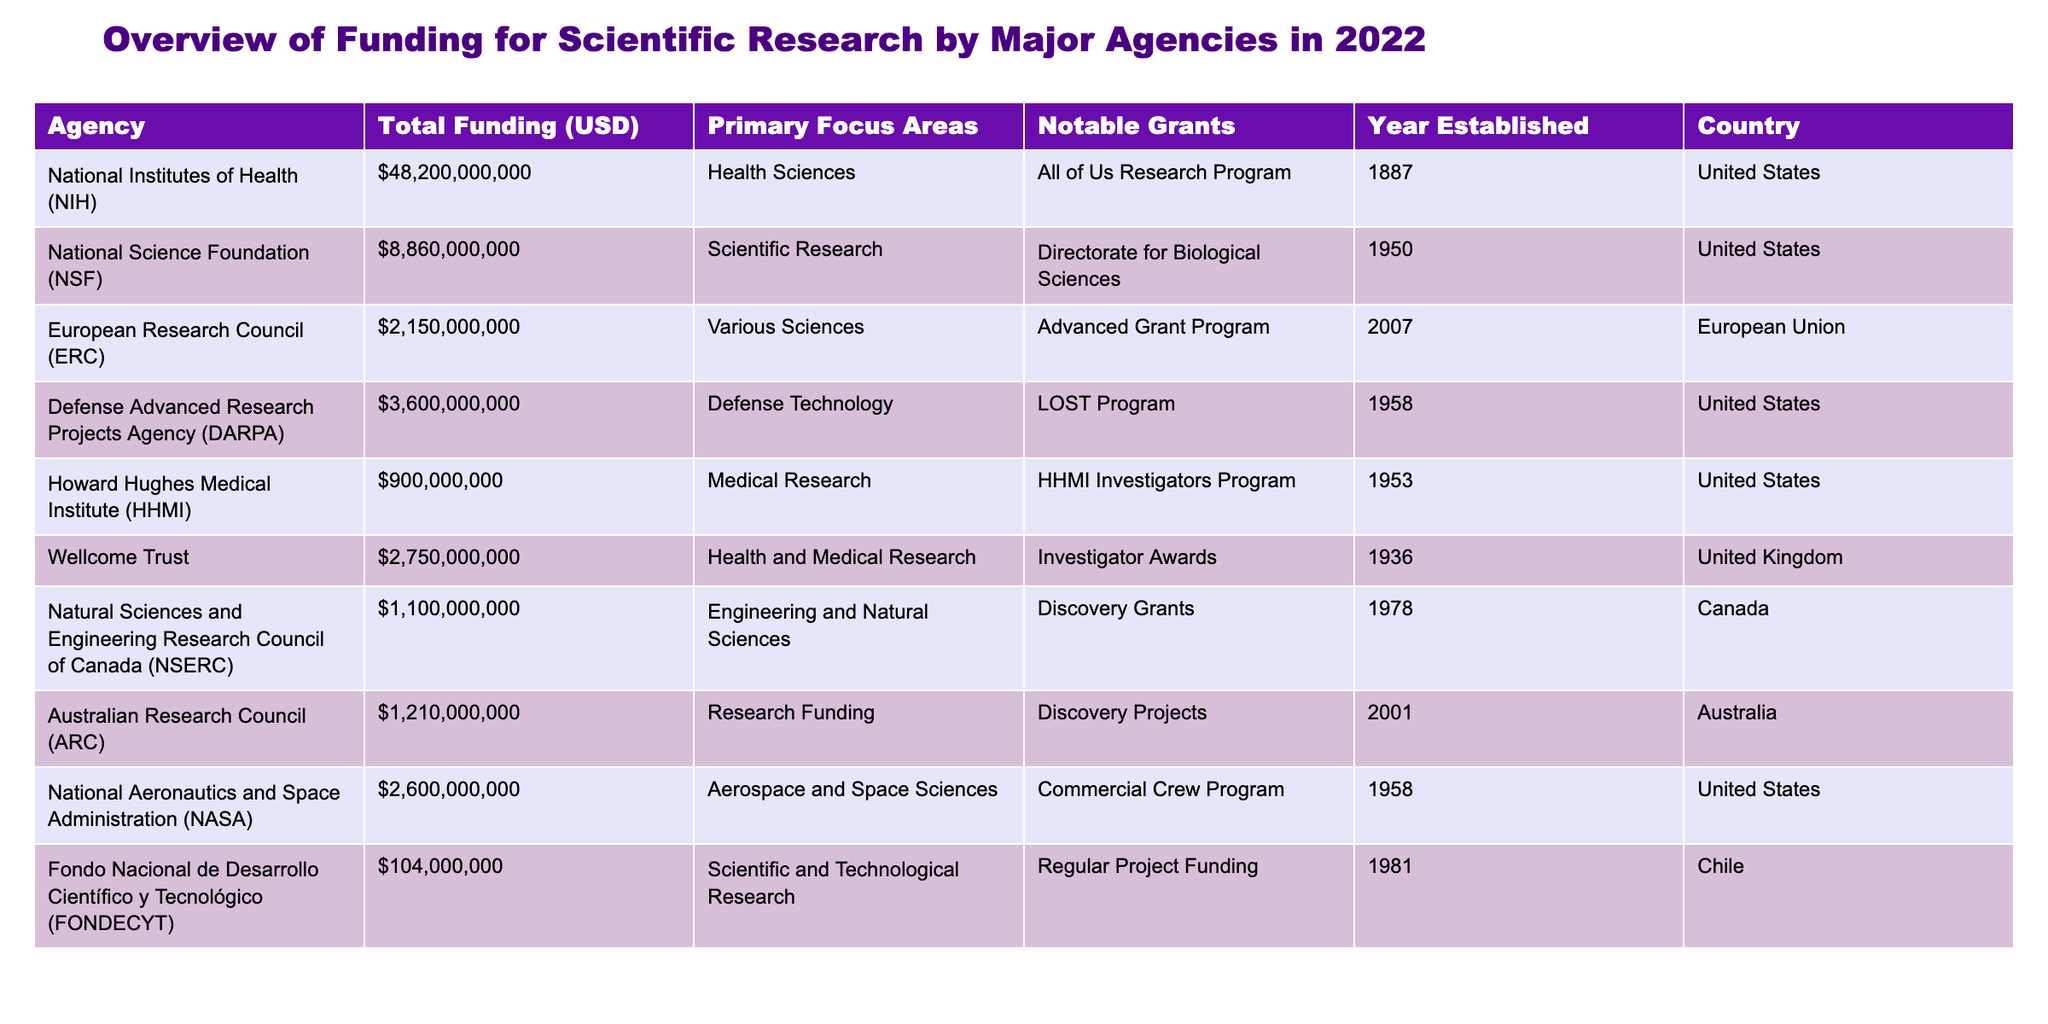What is the total funding provided by the National Institutes of Health (NIH)? The table shows that the total funding provided by the National Institutes of Health (NIH) is USD 48,200,000,000. This can be found in the "Total Funding (USD)" column corresponding to the row for NIH.
Answer: 48,200,000,000 Which agency focuses on defense technology and how much funding did it receive? The agency that focuses on defense technology is the Defense Advanced Research Projects Agency (DARPA), and according to the table, it received USD 3,600,000,000 in funding. This information can be found in the columns for "Agency" and "Total Funding (USD)."
Answer: DARPA, 3,600,000,000 What is the average funding amount for the United States agencies listed in the table? The United States agencies listed are NIH, NSF, DARPA, HHMI, and NASA. Their total funding amounts are: 48,200,000,000 (NIH) + 8,860,000,000 (NSF) + 3,600,000,000 (DARPA) + 900,000,000 (HHMI) + 2,600,000,000 (NASA) = 64,160,000,000. There are 5 agencies, so the average funding is 64,160,000,000 / 5 = 12,832,000,000.
Answer: 12,832,000,000 Does the European Research Council (ERC) provide funding for health sciences? Based on the table, the Primary Focus Areas for the European Research Council (ERC) are listed as "Various Sciences," which does not specifically include health sciences. Therefore, the answer is no.
Answer: No What is the total funding from agencies based in the United States compared to the total funding from overseas agencies? First, we identify the total funding from U.S. agencies: NIH 48,200,000,000 + NSF 8,860,000,000 + DARPA 3,600,000,000 + HHMI 900,000,000 + NASA 2,600,000,000 = 64,160,000,000. For overseas agencies: Wellcome Trust (UK) 2,750,000,000 + ERC (EU) 2,150,000,000 + NSERC (Canada) 1,100,000,000 + ARC (Australia) 1,210,000,000 + FONDECYT (Chile) 104,000,000 = 7,314,000,000. Thus, the U.S. total is significantly larger than the overseas total: 64,160,000,000 vs. 7,314,000,000.
Answer: U.S.: 64,160,000,000; Overseas: 7,314,000,000 What notable grant is associated with the Howard Hughes Medical Institute (HHMI)? The table indicates that the notable grant associated with the Howard Hughes Medical Institute (HHMI) is the "HHMI Investigators Program." This can be found in the "Notable Grants" column corresponding to HHMI.
Answer: HHMI Investigators Program 